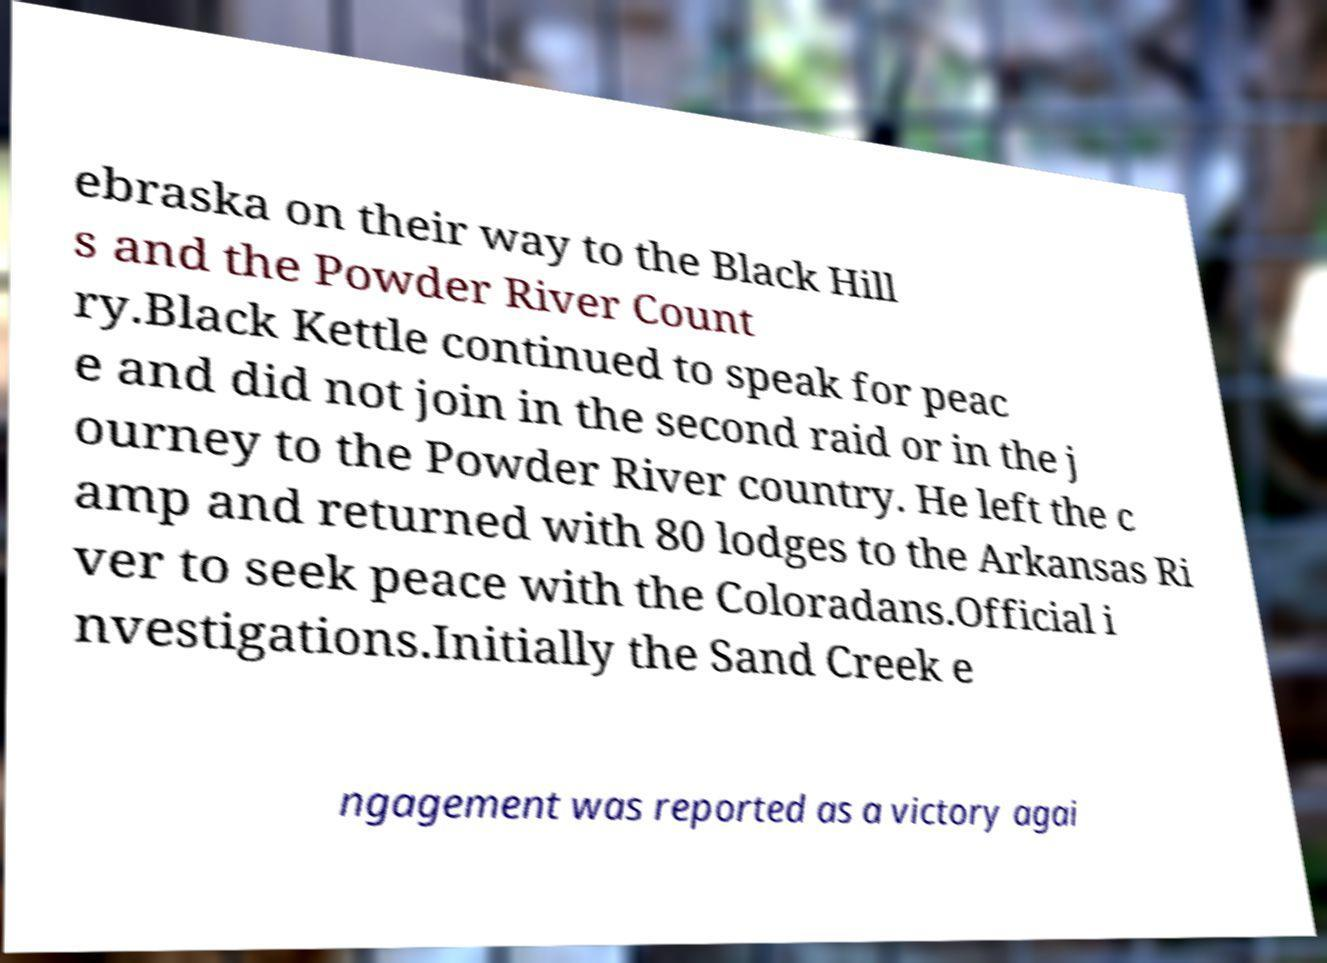Can you accurately transcribe the text from the provided image for me? ebraska on their way to the Black Hill s and the Powder River Count ry.Black Kettle continued to speak for peac e and did not join in the second raid or in the j ourney to the Powder River country. He left the c amp and returned with 80 lodges to the Arkansas Ri ver to seek peace with the Coloradans.Official i nvestigations.Initially the Sand Creek e ngagement was reported as a victory agai 